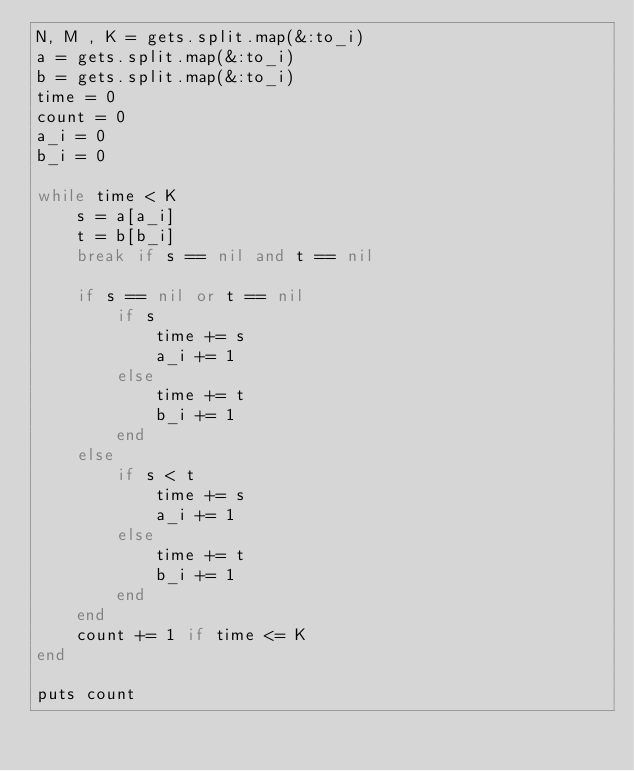<code> <loc_0><loc_0><loc_500><loc_500><_Ruby_>N, M , K = gets.split.map(&:to_i)
a = gets.split.map(&:to_i)
b = gets.split.map(&:to_i)
time = 0
count = 0
a_i = 0
b_i = 0

while time < K
    s = a[a_i]
    t = b[b_i]
    break if s == nil and t == nil   

    if s == nil or t == nil
        if s
            time += s
            a_i += 1
        else
            time += t
            b_i += 1
        end
    else
        if s < t
            time += s
            a_i += 1
        else
            time += t
            b_i += 1
        end 
    end
    count += 1 if time <= K
end

puts count</code> 